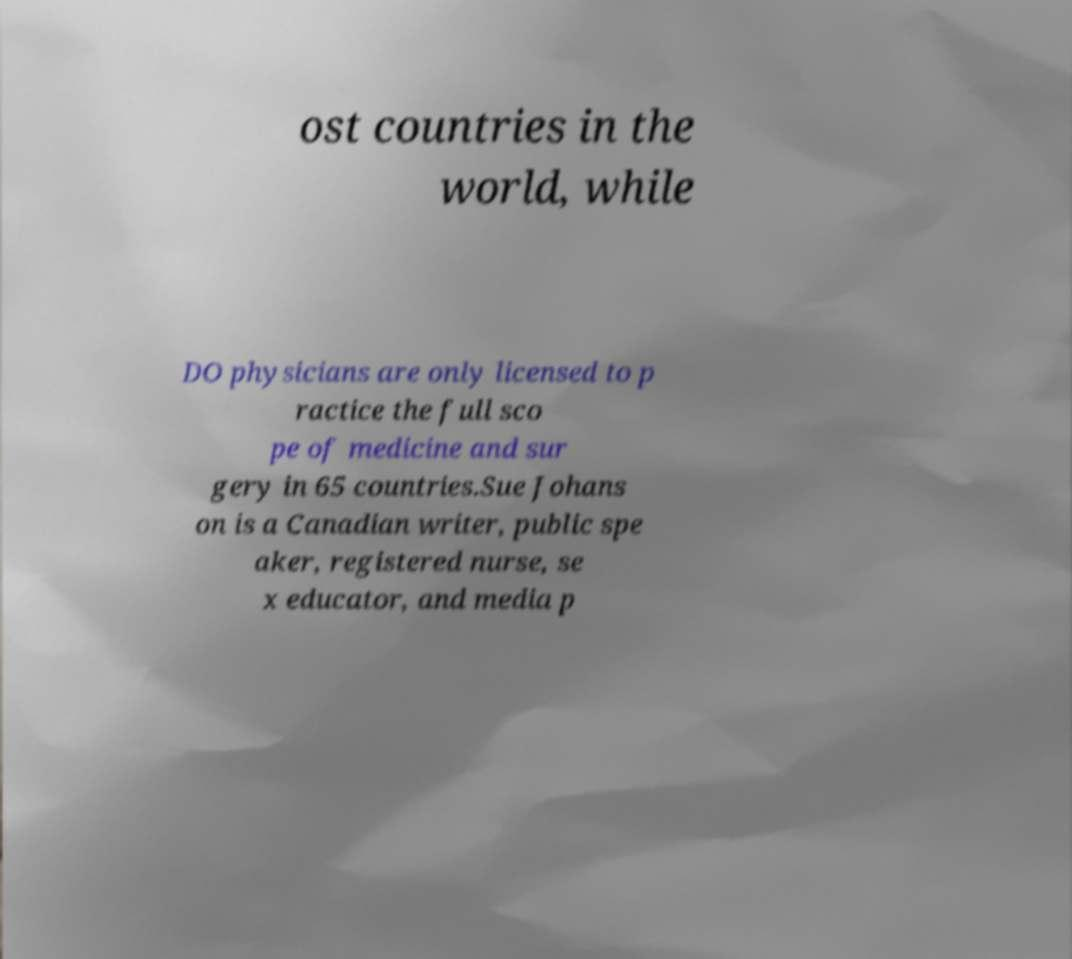For documentation purposes, I need the text within this image transcribed. Could you provide that? ost countries in the world, while DO physicians are only licensed to p ractice the full sco pe of medicine and sur gery in 65 countries.Sue Johans on is a Canadian writer, public spe aker, registered nurse, se x educator, and media p 